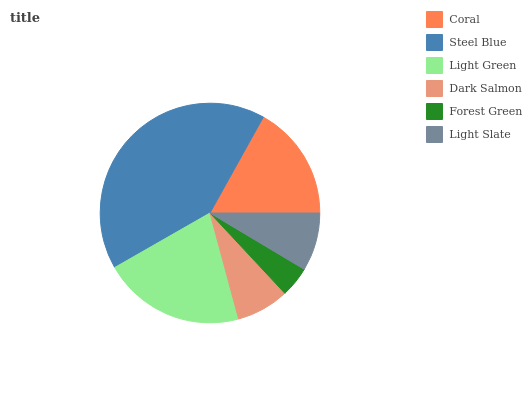Is Forest Green the minimum?
Answer yes or no. Yes. Is Steel Blue the maximum?
Answer yes or no. Yes. Is Light Green the minimum?
Answer yes or no. No. Is Light Green the maximum?
Answer yes or no. No. Is Steel Blue greater than Light Green?
Answer yes or no. Yes. Is Light Green less than Steel Blue?
Answer yes or no. Yes. Is Light Green greater than Steel Blue?
Answer yes or no. No. Is Steel Blue less than Light Green?
Answer yes or no. No. Is Coral the high median?
Answer yes or no. Yes. Is Light Slate the low median?
Answer yes or no. Yes. Is Forest Green the high median?
Answer yes or no. No. Is Steel Blue the low median?
Answer yes or no. No. 